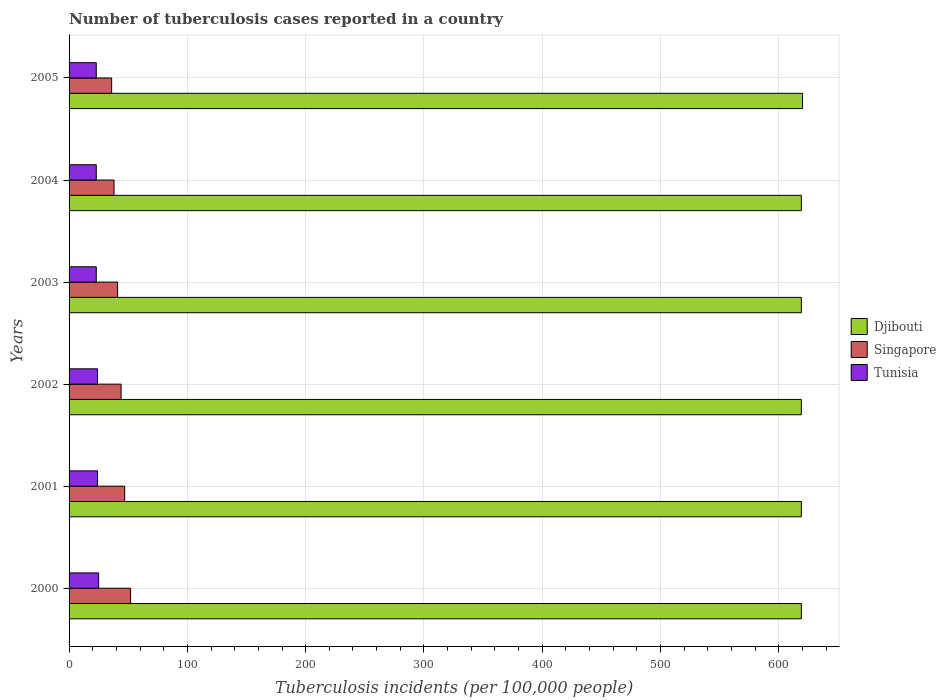How many different coloured bars are there?
Make the answer very short. 3. How many groups of bars are there?
Your response must be concise. 6. Are the number of bars per tick equal to the number of legend labels?
Offer a terse response. Yes. How many bars are there on the 1st tick from the top?
Make the answer very short. 3. What is the label of the 4th group of bars from the top?
Ensure brevity in your answer.  2002. In how many cases, is the number of bars for a given year not equal to the number of legend labels?
Offer a terse response. 0. What is the number of tuberculosis cases reported in in Tunisia in 2004?
Provide a succinct answer. 23. Across all years, what is the maximum number of tuberculosis cases reported in in Tunisia?
Make the answer very short. 25. Across all years, what is the minimum number of tuberculosis cases reported in in Tunisia?
Offer a terse response. 23. What is the total number of tuberculosis cases reported in in Tunisia in the graph?
Provide a succinct answer. 142. What is the difference between the number of tuberculosis cases reported in in Tunisia in 2005 and the number of tuberculosis cases reported in in Singapore in 2000?
Provide a short and direct response. -29. In the year 2005, what is the difference between the number of tuberculosis cases reported in in Tunisia and number of tuberculosis cases reported in in Singapore?
Keep it short and to the point. -13. What is the ratio of the number of tuberculosis cases reported in in Singapore in 2002 to that in 2004?
Keep it short and to the point. 1.16. Is the number of tuberculosis cases reported in in Tunisia in 2003 less than that in 2004?
Offer a very short reply. No. Is the difference between the number of tuberculosis cases reported in in Tunisia in 2002 and 2004 greater than the difference between the number of tuberculosis cases reported in in Singapore in 2002 and 2004?
Offer a terse response. No. What is the difference between the highest and the lowest number of tuberculosis cases reported in in Singapore?
Ensure brevity in your answer.  16. Is the sum of the number of tuberculosis cases reported in in Tunisia in 2000 and 2004 greater than the maximum number of tuberculosis cases reported in in Djibouti across all years?
Your answer should be very brief. No. What does the 3rd bar from the top in 2001 represents?
Your answer should be compact. Djibouti. What does the 1st bar from the bottom in 2000 represents?
Offer a terse response. Djibouti. Is it the case that in every year, the sum of the number of tuberculosis cases reported in in Tunisia and number of tuberculosis cases reported in in Singapore is greater than the number of tuberculosis cases reported in in Djibouti?
Ensure brevity in your answer.  No. Are all the bars in the graph horizontal?
Your answer should be compact. Yes. How many years are there in the graph?
Keep it short and to the point. 6. What is the difference between two consecutive major ticks on the X-axis?
Ensure brevity in your answer.  100. Are the values on the major ticks of X-axis written in scientific E-notation?
Keep it short and to the point. No. Does the graph contain any zero values?
Make the answer very short. No. How many legend labels are there?
Your answer should be very brief. 3. What is the title of the graph?
Your response must be concise. Number of tuberculosis cases reported in a country. Does "Channel Islands" appear as one of the legend labels in the graph?
Your answer should be compact. No. What is the label or title of the X-axis?
Ensure brevity in your answer.  Tuberculosis incidents (per 100,0 people). What is the Tuberculosis incidents (per 100,000 people) of Djibouti in 2000?
Provide a succinct answer. 619. What is the Tuberculosis incidents (per 100,000 people) in Djibouti in 2001?
Provide a short and direct response. 619. What is the Tuberculosis incidents (per 100,000 people) in Singapore in 2001?
Your answer should be compact. 47. What is the Tuberculosis incidents (per 100,000 people) in Tunisia in 2001?
Provide a succinct answer. 24. What is the Tuberculosis incidents (per 100,000 people) of Djibouti in 2002?
Ensure brevity in your answer.  619. What is the Tuberculosis incidents (per 100,000 people) of Singapore in 2002?
Give a very brief answer. 44. What is the Tuberculosis incidents (per 100,000 people) of Tunisia in 2002?
Offer a terse response. 24. What is the Tuberculosis incidents (per 100,000 people) of Djibouti in 2003?
Provide a short and direct response. 619. What is the Tuberculosis incidents (per 100,000 people) in Djibouti in 2004?
Provide a short and direct response. 619. What is the Tuberculosis incidents (per 100,000 people) of Singapore in 2004?
Ensure brevity in your answer.  38. What is the Tuberculosis incidents (per 100,000 people) of Djibouti in 2005?
Your response must be concise. 620. Across all years, what is the maximum Tuberculosis incidents (per 100,000 people) of Djibouti?
Your answer should be compact. 620. Across all years, what is the maximum Tuberculosis incidents (per 100,000 people) in Tunisia?
Provide a succinct answer. 25. Across all years, what is the minimum Tuberculosis incidents (per 100,000 people) of Djibouti?
Give a very brief answer. 619. Across all years, what is the minimum Tuberculosis incidents (per 100,000 people) of Singapore?
Your answer should be very brief. 36. What is the total Tuberculosis incidents (per 100,000 people) in Djibouti in the graph?
Give a very brief answer. 3715. What is the total Tuberculosis incidents (per 100,000 people) of Singapore in the graph?
Your answer should be compact. 258. What is the total Tuberculosis incidents (per 100,000 people) in Tunisia in the graph?
Give a very brief answer. 142. What is the difference between the Tuberculosis incidents (per 100,000 people) of Singapore in 2000 and that in 2001?
Offer a very short reply. 5. What is the difference between the Tuberculosis incidents (per 100,000 people) in Tunisia in 2000 and that in 2001?
Offer a very short reply. 1. What is the difference between the Tuberculosis incidents (per 100,000 people) in Djibouti in 2000 and that in 2002?
Provide a succinct answer. 0. What is the difference between the Tuberculosis incidents (per 100,000 people) of Singapore in 2000 and that in 2002?
Your answer should be compact. 8. What is the difference between the Tuberculosis incidents (per 100,000 people) of Djibouti in 2000 and that in 2003?
Ensure brevity in your answer.  0. What is the difference between the Tuberculosis incidents (per 100,000 people) in Djibouti in 2000 and that in 2004?
Provide a short and direct response. 0. What is the difference between the Tuberculosis incidents (per 100,000 people) of Djibouti in 2000 and that in 2005?
Your answer should be compact. -1. What is the difference between the Tuberculosis incidents (per 100,000 people) in Singapore in 2000 and that in 2005?
Provide a succinct answer. 16. What is the difference between the Tuberculosis incidents (per 100,000 people) in Tunisia in 2000 and that in 2005?
Ensure brevity in your answer.  2. What is the difference between the Tuberculosis incidents (per 100,000 people) of Tunisia in 2001 and that in 2002?
Your response must be concise. 0. What is the difference between the Tuberculosis incidents (per 100,000 people) of Singapore in 2001 and that in 2003?
Provide a succinct answer. 6. What is the difference between the Tuberculosis incidents (per 100,000 people) of Tunisia in 2001 and that in 2003?
Ensure brevity in your answer.  1. What is the difference between the Tuberculosis incidents (per 100,000 people) of Djibouti in 2001 and that in 2004?
Your response must be concise. 0. What is the difference between the Tuberculosis incidents (per 100,000 people) in Singapore in 2001 and that in 2004?
Your answer should be compact. 9. What is the difference between the Tuberculosis incidents (per 100,000 people) in Tunisia in 2001 and that in 2004?
Provide a succinct answer. 1. What is the difference between the Tuberculosis incidents (per 100,000 people) in Singapore in 2001 and that in 2005?
Ensure brevity in your answer.  11. What is the difference between the Tuberculosis incidents (per 100,000 people) in Tunisia in 2001 and that in 2005?
Offer a terse response. 1. What is the difference between the Tuberculosis incidents (per 100,000 people) of Djibouti in 2002 and that in 2003?
Your response must be concise. 0. What is the difference between the Tuberculosis incidents (per 100,000 people) in Singapore in 2002 and that in 2003?
Your response must be concise. 3. What is the difference between the Tuberculosis incidents (per 100,000 people) in Singapore in 2002 and that in 2004?
Keep it short and to the point. 6. What is the difference between the Tuberculosis incidents (per 100,000 people) in Tunisia in 2002 and that in 2004?
Make the answer very short. 1. What is the difference between the Tuberculosis incidents (per 100,000 people) in Tunisia in 2002 and that in 2005?
Offer a very short reply. 1. What is the difference between the Tuberculosis incidents (per 100,000 people) of Djibouti in 2003 and that in 2004?
Give a very brief answer. 0. What is the difference between the Tuberculosis incidents (per 100,000 people) in Singapore in 2003 and that in 2004?
Provide a short and direct response. 3. What is the difference between the Tuberculosis incidents (per 100,000 people) in Tunisia in 2003 and that in 2004?
Give a very brief answer. 0. What is the difference between the Tuberculosis incidents (per 100,000 people) in Tunisia in 2004 and that in 2005?
Give a very brief answer. 0. What is the difference between the Tuberculosis incidents (per 100,000 people) of Djibouti in 2000 and the Tuberculosis incidents (per 100,000 people) of Singapore in 2001?
Ensure brevity in your answer.  572. What is the difference between the Tuberculosis incidents (per 100,000 people) in Djibouti in 2000 and the Tuberculosis incidents (per 100,000 people) in Tunisia in 2001?
Make the answer very short. 595. What is the difference between the Tuberculosis incidents (per 100,000 people) in Djibouti in 2000 and the Tuberculosis incidents (per 100,000 people) in Singapore in 2002?
Provide a succinct answer. 575. What is the difference between the Tuberculosis incidents (per 100,000 people) in Djibouti in 2000 and the Tuberculosis incidents (per 100,000 people) in Tunisia in 2002?
Your response must be concise. 595. What is the difference between the Tuberculosis incidents (per 100,000 people) in Singapore in 2000 and the Tuberculosis incidents (per 100,000 people) in Tunisia in 2002?
Provide a short and direct response. 28. What is the difference between the Tuberculosis incidents (per 100,000 people) of Djibouti in 2000 and the Tuberculosis incidents (per 100,000 people) of Singapore in 2003?
Keep it short and to the point. 578. What is the difference between the Tuberculosis incidents (per 100,000 people) in Djibouti in 2000 and the Tuberculosis incidents (per 100,000 people) in Tunisia in 2003?
Your response must be concise. 596. What is the difference between the Tuberculosis incidents (per 100,000 people) in Djibouti in 2000 and the Tuberculosis incidents (per 100,000 people) in Singapore in 2004?
Your answer should be very brief. 581. What is the difference between the Tuberculosis incidents (per 100,000 people) in Djibouti in 2000 and the Tuberculosis incidents (per 100,000 people) in Tunisia in 2004?
Give a very brief answer. 596. What is the difference between the Tuberculosis incidents (per 100,000 people) of Singapore in 2000 and the Tuberculosis incidents (per 100,000 people) of Tunisia in 2004?
Give a very brief answer. 29. What is the difference between the Tuberculosis incidents (per 100,000 people) of Djibouti in 2000 and the Tuberculosis incidents (per 100,000 people) of Singapore in 2005?
Your response must be concise. 583. What is the difference between the Tuberculosis incidents (per 100,000 people) of Djibouti in 2000 and the Tuberculosis incidents (per 100,000 people) of Tunisia in 2005?
Provide a short and direct response. 596. What is the difference between the Tuberculosis incidents (per 100,000 people) in Djibouti in 2001 and the Tuberculosis incidents (per 100,000 people) in Singapore in 2002?
Your answer should be very brief. 575. What is the difference between the Tuberculosis incidents (per 100,000 people) in Djibouti in 2001 and the Tuberculosis incidents (per 100,000 people) in Tunisia in 2002?
Your answer should be very brief. 595. What is the difference between the Tuberculosis incidents (per 100,000 people) of Djibouti in 2001 and the Tuberculosis incidents (per 100,000 people) of Singapore in 2003?
Make the answer very short. 578. What is the difference between the Tuberculosis incidents (per 100,000 people) of Djibouti in 2001 and the Tuberculosis incidents (per 100,000 people) of Tunisia in 2003?
Make the answer very short. 596. What is the difference between the Tuberculosis incidents (per 100,000 people) of Djibouti in 2001 and the Tuberculosis incidents (per 100,000 people) of Singapore in 2004?
Your response must be concise. 581. What is the difference between the Tuberculosis incidents (per 100,000 people) of Djibouti in 2001 and the Tuberculosis incidents (per 100,000 people) of Tunisia in 2004?
Your response must be concise. 596. What is the difference between the Tuberculosis incidents (per 100,000 people) in Djibouti in 2001 and the Tuberculosis incidents (per 100,000 people) in Singapore in 2005?
Offer a very short reply. 583. What is the difference between the Tuberculosis incidents (per 100,000 people) of Djibouti in 2001 and the Tuberculosis incidents (per 100,000 people) of Tunisia in 2005?
Offer a very short reply. 596. What is the difference between the Tuberculosis incidents (per 100,000 people) in Singapore in 2001 and the Tuberculosis incidents (per 100,000 people) in Tunisia in 2005?
Provide a short and direct response. 24. What is the difference between the Tuberculosis incidents (per 100,000 people) in Djibouti in 2002 and the Tuberculosis incidents (per 100,000 people) in Singapore in 2003?
Provide a short and direct response. 578. What is the difference between the Tuberculosis incidents (per 100,000 people) of Djibouti in 2002 and the Tuberculosis incidents (per 100,000 people) of Tunisia in 2003?
Your response must be concise. 596. What is the difference between the Tuberculosis incidents (per 100,000 people) in Djibouti in 2002 and the Tuberculosis incidents (per 100,000 people) in Singapore in 2004?
Give a very brief answer. 581. What is the difference between the Tuberculosis incidents (per 100,000 people) of Djibouti in 2002 and the Tuberculosis incidents (per 100,000 people) of Tunisia in 2004?
Your response must be concise. 596. What is the difference between the Tuberculosis incidents (per 100,000 people) of Singapore in 2002 and the Tuberculosis incidents (per 100,000 people) of Tunisia in 2004?
Your response must be concise. 21. What is the difference between the Tuberculosis incidents (per 100,000 people) of Djibouti in 2002 and the Tuberculosis incidents (per 100,000 people) of Singapore in 2005?
Offer a terse response. 583. What is the difference between the Tuberculosis incidents (per 100,000 people) of Djibouti in 2002 and the Tuberculosis incidents (per 100,000 people) of Tunisia in 2005?
Give a very brief answer. 596. What is the difference between the Tuberculosis incidents (per 100,000 people) in Djibouti in 2003 and the Tuberculosis incidents (per 100,000 people) in Singapore in 2004?
Your answer should be very brief. 581. What is the difference between the Tuberculosis incidents (per 100,000 people) in Djibouti in 2003 and the Tuberculosis incidents (per 100,000 people) in Tunisia in 2004?
Give a very brief answer. 596. What is the difference between the Tuberculosis incidents (per 100,000 people) in Singapore in 2003 and the Tuberculosis incidents (per 100,000 people) in Tunisia in 2004?
Ensure brevity in your answer.  18. What is the difference between the Tuberculosis incidents (per 100,000 people) in Djibouti in 2003 and the Tuberculosis incidents (per 100,000 people) in Singapore in 2005?
Offer a terse response. 583. What is the difference between the Tuberculosis incidents (per 100,000 people) in Djibouti in 2003 and the Tuberculosis incidents (per 100,000 people) in Tunisia in 2005?
Offer a very short reply. 596. What is the difference between the Tuberculosis incidents (per 100,000 people) in Singapore in 2003 and the Tuberculosis incidents (per 100,000 people) in Tunisia in 2005?
Ensure brevity in your answer.  18. What is the difference between the Tuberculosis incidents (per 100,000 people) in Djibouti in 2004 and the Tuberculosis incidents (per 100,000 people) in Singapore in 2005?
Ensure brevity in your answer.  583. What is the difference between the Tuberculosis incidents (per 100,000 people) in Djibouti in 2004 and the Tuberculosis incidents (per 100,000 people) in Tunisia in 2005?
Offer a very short reply. 596. What is the difference between the Tuberculosis incidents (per 100,000 people) of Singapore in 2004 and the Tuberculosis incidents (per 100,000 people) of Tunisia in 2005?
Ensure brevity in your answer.  15. What is the average Tuberculosis incidents (per 100,000 people) of Djibouti per year?
Your response must be concise. 619.17. What is the average Tuberculosis incidents (per 100,000 people) of Tunisia per year?
Offer a very short reply. 23.67. In the year 2000, what is the difference between the Tuberculosis incidents (per 100,000 people) in Djibouti and Tuberculosis incidents (per 100,000 people) in Singapore?
Your response must be concise. 567. In the year 2000, what is the difference between the Tuberculosis incidents (per 100,000 people) in Djibouti and Tuberculosis incidents (per 100,000 people) in Tunisia?
Offer a terse response. 594. In the year 2001, what is the difference between the Tuberculosis incidents (per 100,000 people) in Djibouti and Tuberculosis incidents (per 100,000 people) in Singapore?
Ensure brevity in your answer.  572. In the year 2001, what is the difference between the Tuberculosis incidents (per 100,000 people) in Djibouti and Tuberculosis incidents (per 100,000 people) in Tunisia?
Your answer should be very brief. 595. In the year 2001, what is the difference between the Tuberculosis incidents (per 100,000 people) of Singapore and Tuberculosis incidents (per 100,000 people) of Tunisia?
Offer a very short reply. 23. In the year 2002, what is the difference between the Tuberculosis incidents (per 100,000 people) of Djibouti and Tuberculosis incidents (per 100,000 people) of Singapore?
Keep it short and to the point. 575. In the year 2002, what is the difference between the Tuberculosis incidents (per 100,000 people) of Djibouti and Tuberculosis incidents (per 100,000 people) of Tunisia?
Give a very brief answer. 595. In the year 2002, what is the difference between the Tuberculosis incidents (per 100,000 people) in Singapore and Tuberculosis incidents (per 100,000 people) in Tunisia?
Make the answer very short. 20. In the year 2003, what is the difference between the Tuberculosis incidents (per 100,000 people) in Djibouti and Tuberculosis incidents (per 100,000 people) in Singapore?
Your response must be concise. 578. In the year 2003, what is the difference between the Tuberculosis incidents (per 100,000 people) of Djibouti and Tuberculosis incidents (per 100,000 people) of Tunisia?
Make the answer very short. 596. In the year 2004, what is the difference between the Tuberculosis incidents (per 100,000 people) of Djibouti and Tuberculosis incidents (per 100,000 people) of Singapore?
Offer a very short reply. 581. In the year 2004, what is the difference between the Tuberculosis incidents (per 100,000 people) of Djibouti and Tuberculosis incidents (per 100,000 people) of Tunisia?
Make the answer very short. 596. In the year 2005, what is the difference between the Tuberculosis incidents (per 100,000 people) of Djibouti and Tuberculosis incidents (per 100,000 people) of Singapore?
Give a very brief answer. 584. In the year 2005, what is the difference between the Tuberculosis incidents (per 100,000 people) in Djibouti and Tuberculosis incidents (per 100,000 people) in Tunisia?
Ensure brevity in your answer.  597. What is the ratio of the Tuberculosis incidents (per 100,000 people) of Singapore in 2000 to that in 2001?
Keep it short and to the point. 1.11. What is the ratio of the Tuberculosis incidents (per 100,000 people) of Tunisia in 2000 to that in 2001?
Offer a very short reply. 1.04. What is the ratio of the Tuberculosis incidents (per 100,000 people) in Djibouti in 2000 to that in 2002?
Offer a very short reply. 1. What is the ratio of the Tuberculosis incidents (per 100,000 people) in Singapore in 2000 to that in 2002?
Keep it short and to the point. 1.18. What is the ratio of the Tuberculosis incidents (per 100,000 people) of Tunisia in 2000 to that in 2002?
Your answer should be compact. 1.04. What is the ratio of the Tuberculosis incidents (per 100,000 people) in Singapore in 2000 to that in 2003?
Keep it short and to the point. 1.27. What is the ratio of the Tuberculosis incidents (per 100,000 people) in Tunisia in 2000 to that in 2003?
Ensure brevity in your answer.  1.09. What is the ratio of the Tuberculosis incidents (per 100,000 people) in Singapore in 2000 to that in 2004?
Make the answer very short. 1.37. What is the ratio of the Tuberculosis incidents (per 100,000 people) in Tunisia in 2000 to that in 2004?
Offer a terse response. 1.09. What is the ratio of the Tuberculosis incidents (per 100,000 people) in Singapore in 2000 to that in 2005?
Make the answer very short. 1.44. What is the ratio of the Tuberculosis incidents (per 100,000 people) in Tunisia in 2000 to that in 2005?
Your response must be concise. 1.09. What is the ratio of the Tuberculosis incidents (per 100,000 people) in Djibouti in 2001 to that in 2002?
Provide a succinct answer. 1. What is the ratio of the Tuberculosis incidents (per 100,000 people) in Singapore in 2001 to that in 2002?
Offer a very short reply. 1.07. What is the ratio of the Tuberculosis incidents (per 100,000 people) of Singapore in 2001 to that in 2003?
Offer a very short reply. 1.15. What is the ratio of the Tuberculosis incidents (per 100,000 people) of Tunisia in 2001 to that in 2003?
Your answer should be very brief. 1.04. What is the ratio of the Tuberculosis incidents (per 100,000 people) of Djibouti in 2001 to that in 2004?
Provide a succinct answer. 1. What is the ratio of the Tuberculosis incidents (per 100,000 people) in Singapore in 2001 to that in 2004?
Give a very brief answer. 1.24. What is the ratio of the Tuberculosis incidents (per 100,000 people) of Tunisia in 2001 to that in 2004?
Offer a terse response. 1.04. What is the ratio of the Tuberculosis incidents (per 100,000 people) in Djibouti in 2001 to that in 2005?
Keep it short and to the point. 1. What is the ratio of the Tuberculosis incidents (per 100,000 people) of Singapore in 2001 to that in 2005?
Your answer should be compact. 1.31. What is the ratio of the Tuberculosis incidents (per 100,000 people) of Tunisia in 2001 to that in 2005?
Give a very brief answer. 1.04. What is the ratio of the Tuberculosis incidents (per 100,000 people) in Djibouti in 2002 to that in 2003?
Provide a succinct answer. 1. What is the ratio of the Tuberculosis incidents (per 100,000 people) of Singapore in 2002 to that in 2003?
Your answer should be very brief. 1.07. What is the ratio of the Tuberculosis incidents (per 100,000 people) of Tunisia in 2002 to that in 2003?
Provide a short and direct response. 1.04. What is the ratio of the Tuberculosis incidents (per 100,000 people) in Singapore in 2002 to that in 2004?
Make the answer very short. 1.16. What is the ratio of the Tuberculosis incidents (per 100,000 people) of Tunisia in 2002 to that in 2004?
Keep it short and to the point. 1.04. What is the ratio of the Tuberculosis incidents (per 100,000 people) of Djibouti in 2002 to that in 2005?
Your answer should be very brief. 1. What is the ratio of the Tuberculosis incidents (per 100,000 people) of Singapore in 2002 to that in 2005?
Offer a terse response. 1.22. What is the ratio of the Tuberculosis incidents (per 100,000 people) in Tunisia in 2002 to that in 2005?
Ensure brevity in your answer.  1.04. What is the ratio of the Tuberculosis incidents (per 100,000 people) of Djibouti in 2003 to that in 2004?
Your answer should be compact. 1. What is the ratio of the Tuberculosis incidents (per 100,000 people) of Singapore in 2003 to that in 2004?
Your response must be concise. 1.08. What is the ratio of the Tuberculosis incidents (per 100,000 people) of Djibouti in 2003 to that in 2005?
Offer a very short reply. 1. What is the ratio of the Tuberculosis incidents (per 100,000 people) of Singapore in 2003 to that in 2005?
Provide a succinct answer. 1.14. What is the ratio of the Tuberculosis incidents (per 100,000 people) of Tunisia in 2003 to that in 2005?
Your answer should be compact. 1. What is the ratio of the Tuberculosis incidents (per 100,000 people) in Singapore in 2004 to that in 2005?
Offer a very short reply. 1.06. What is the difference between the highest and the second highest Tuberculosis incidents (per 100,000 people) of Djibouti?
Offer a very short reply. 1. What is the difference between the highest and the second highest Tuberculosis incidents (per 100,000 people) in Tunisia?
Offer a very short reply. 1. 